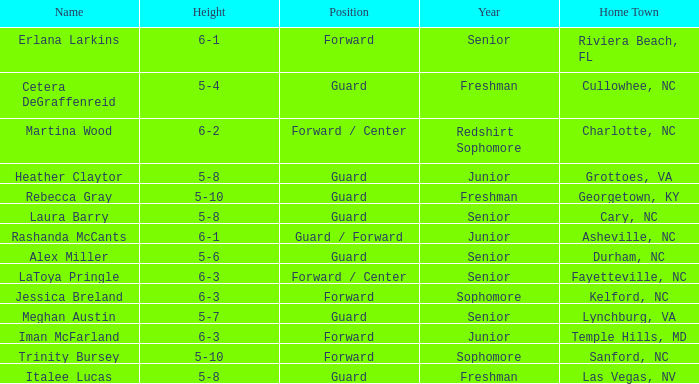What is the height of the player from Las Vegas, NV? 5-8. 